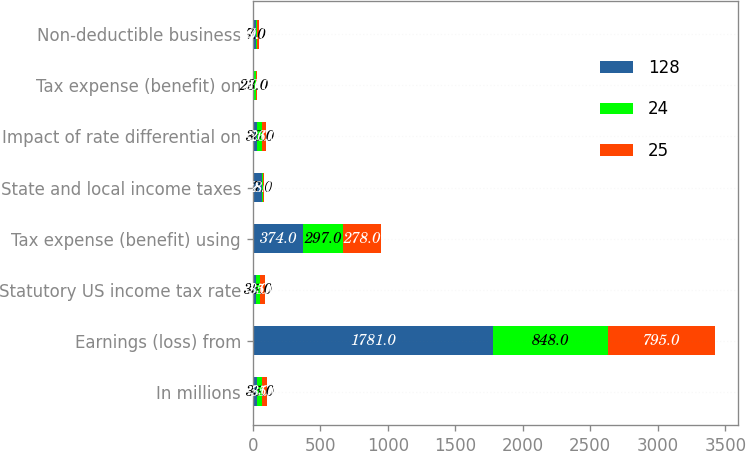<chart> <loc_0><loc_0><loc_500><loc_500><stacked_bar_chart><ecel><fcel>In millions<fcel>Earnings (loss) from<fcel>Statutory US income tax rate<fcel>Tax expense (benefit) using<fcel>State and local income taxes<fcel>Impact of rate differential on<fcel>Tax expense (benefit) on<fcel>Non-deductible business<nl><fcel>128<fcel>35<fcel>1781<fcel>21<fcel>374<fcel>72<fcel>35<fcel>1<fcel>27<nl><fcel>24<fcel>35<fcel>848<fcel>35<fcel>297<fcel>7<fcel>36<fcel>23<fcel>7<nl><fcel>25<fcel>35<fcel>795<fcel>35<fcel>278<fcel>8<fcel>26<fcel>10<fcel>9<nl></chart> 